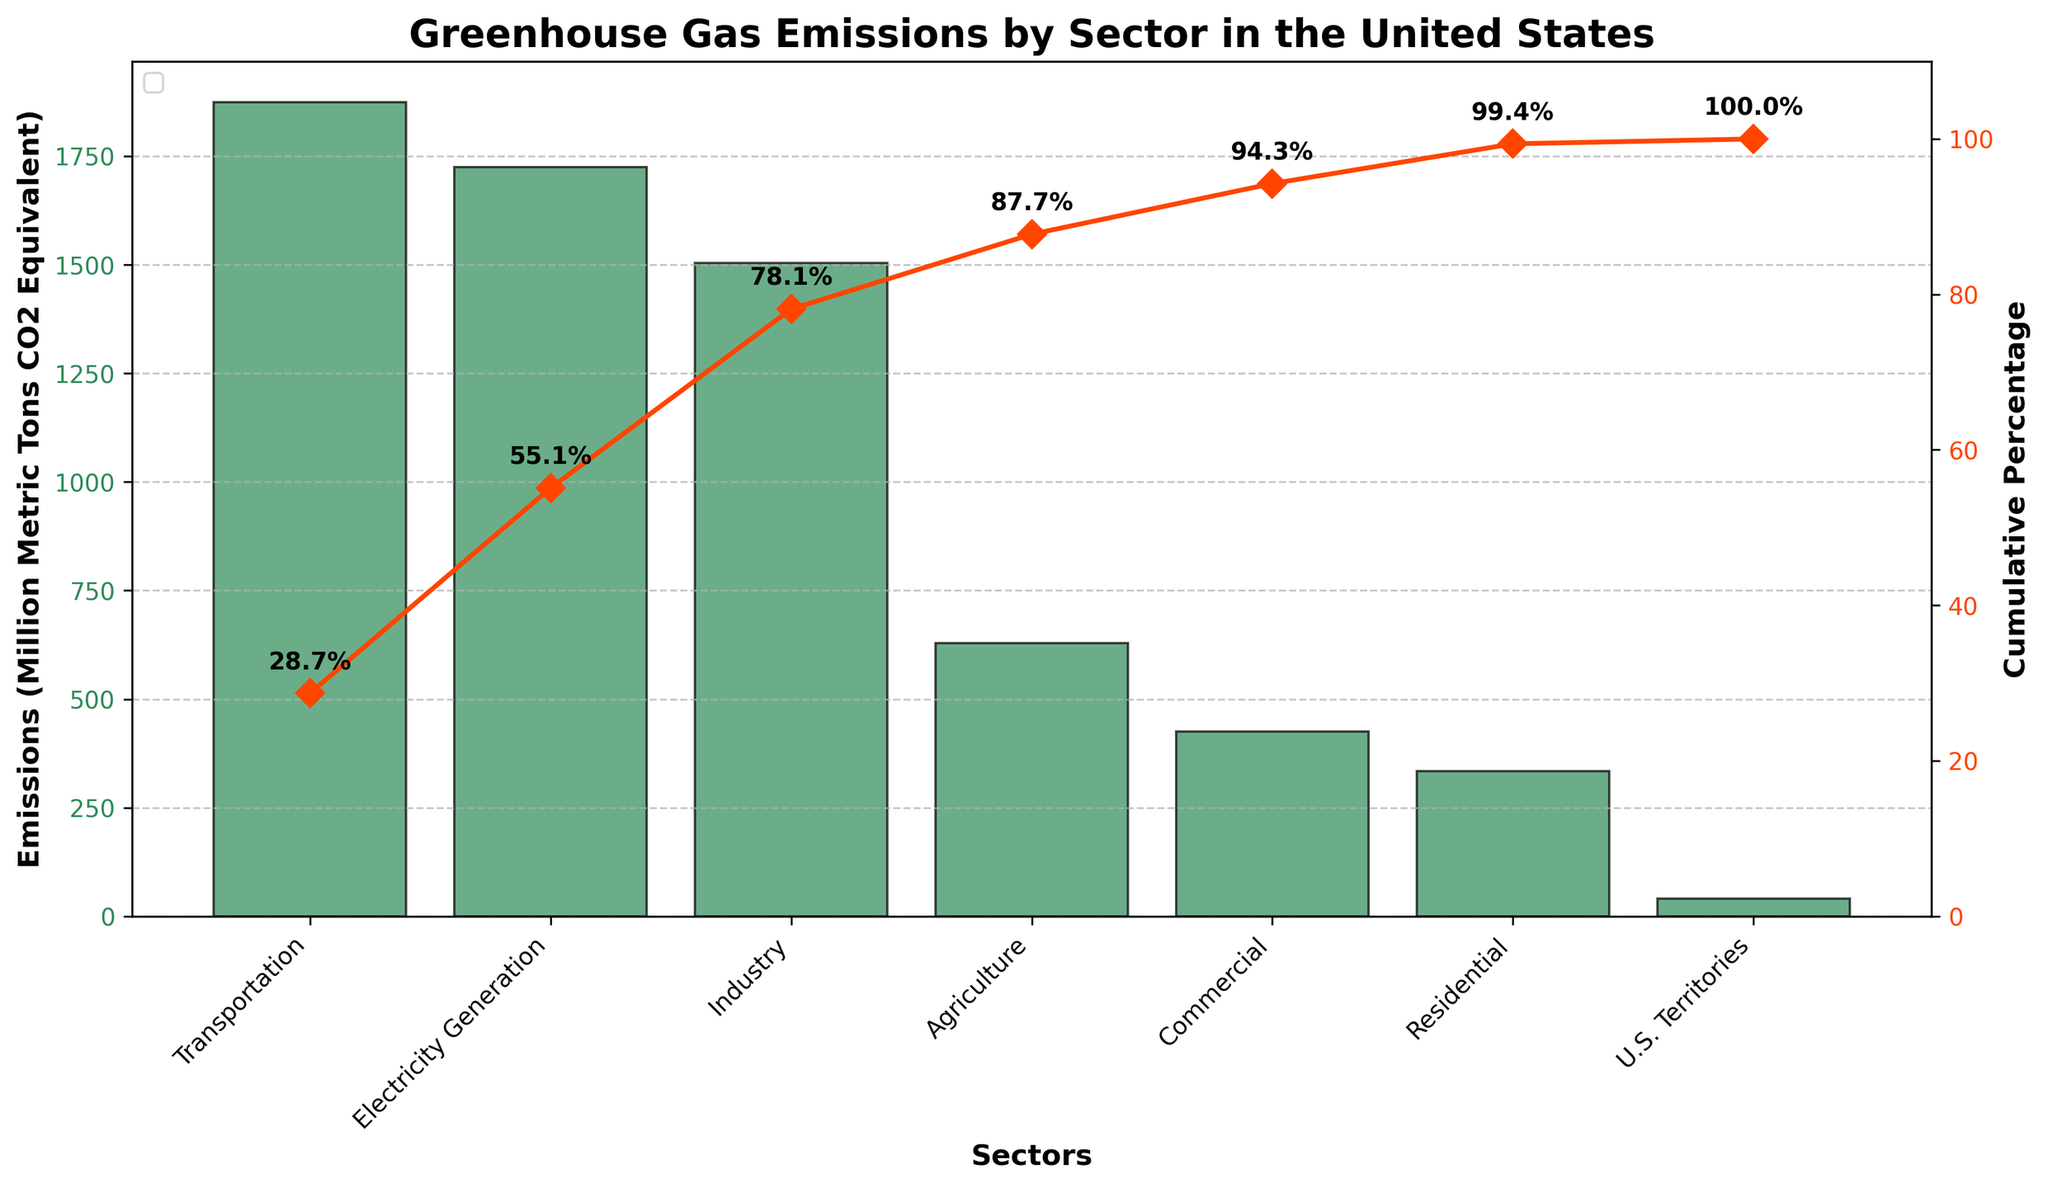What is the title of the figure? The title is usually located at the top center of the figure. In this case, the title reads "Greenhouse Gas Emissions by Sector in the United States".
Answer: Greenhouse Gas Emissions by Sector in the United States Which sector has the highest greenhouse gas emissions? The sector with the tallest bar will have the highest emissions. Here, the Transportation sector has the tallest bar.
Answer: Transportation What is the cumulative percentage of emissions after the top three sectors? To find the cumulative percentage, refer to the line plot for the cumulative percentage. The top three sectors are Transportation, Electricity Generation, and Industry. The cumulative percentage after these sectors is around 76%.
Answer: 76% How many sectors are represented in the figure? Count the number of different bars or labels on the x-axis. There are seven sectors represented.
Answer: 7 What is the difference in emissions between the Industry and Commercial sectors? The emissions for Industry are 1504 million metric tons, and for Commercial, it's 426 million metric tons. Subtract Commercial from Industry: 1504 - 426 = 1078.
Answer: 1078 How much higher are emissions from Transportation compared to Residential? The emissions from Transportation are 1875 million metric tons, and from Residential, it's 334 million metric tons. Subtract Residential from Transportation: 1875 - 334 = 1541.
Answer: 1541 Which sector contributes the least to greenhouse gas emissions? The sector with the shortest bar will have the least emissions. Here, U.S. Territories has the shortest bar.
Answer: U.S. Territories What percentage of total emissions is contributed by the Agricultural sector? The cumulative percentage line plot is approximately 76% before Agriculture and increases after, indicating the Agriculture sector contributes around 10% to the total emissions.
Answer: 10% Do the top two sectors contribute to more than 50% of total emissions? The cumulative percentage after the Transportation and Electricity Generation sectors is about 52%. Hence, they do contribute to more than 50% of total emissions.
Answer: Yes 